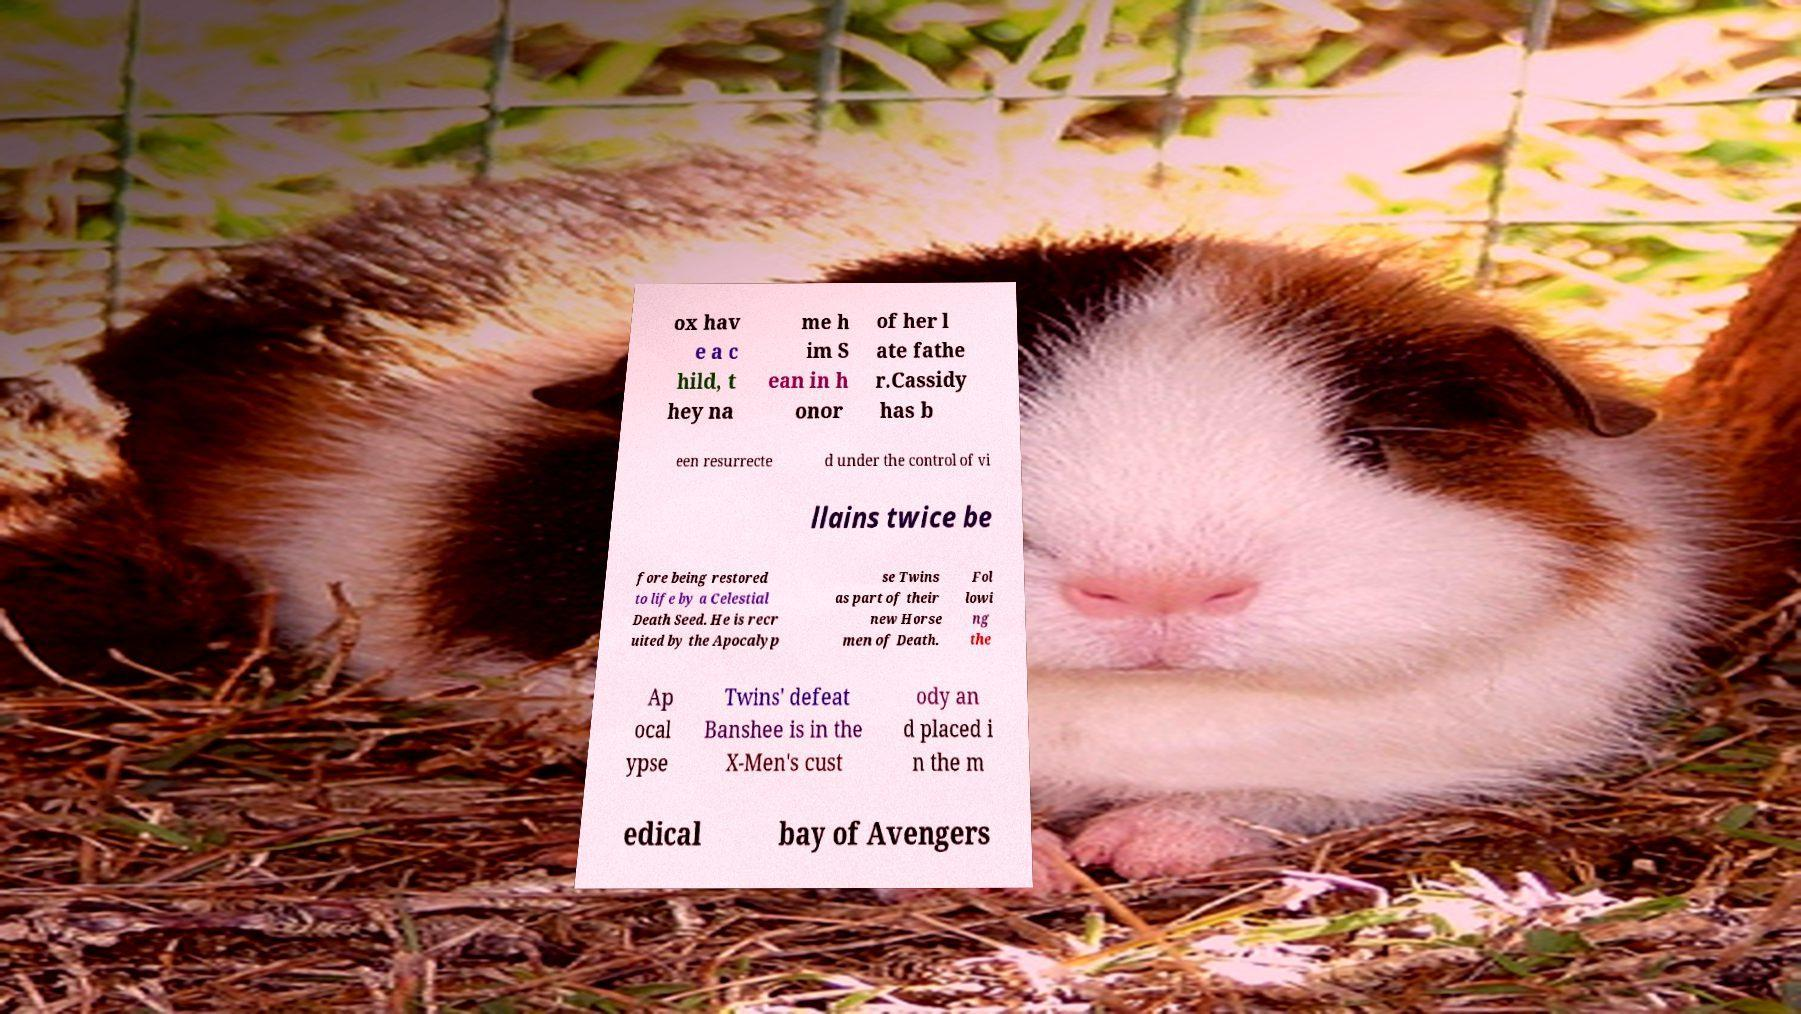Could you assist in decoding the text presented in this image and type it out clearly? ox hav e a c hild, t hey na me h im S ean in h onor of her l ate fathe r.Cassidy has b een resurrecte d under the control of vi llains twice be fore being restored to life by a Celestial Death Seed. He is recr uited by the Apocalyp se Twins as part of their new Horse men of Death. Fol lowi ng the Ap ocal ypse Twins' defeat Banshee is in the X-Men's cust ody an d placed i n the m edical bay of Avengers 